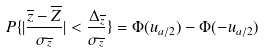<formula> <loc_0><loc_0><loc_500><loc_500>P \{ | \frac { \overline { z } - \overline { Z } } { \sigma _ { \overline { z } } } | < \frac { \Delta _ { \overline { z } } } { \sigma _ { \overline { z } } } \} = \Phi ( u _ { a / 2 } ) - \Phi ( - u _ { a / 2 } )</formula> 